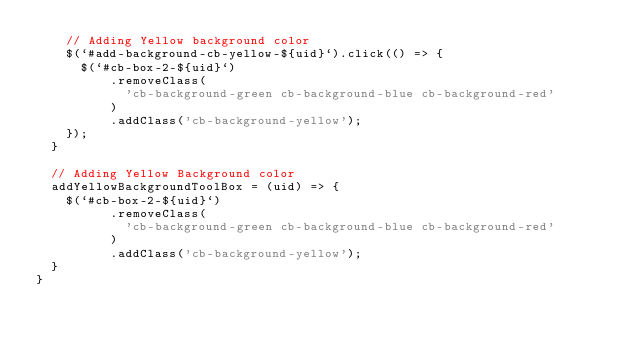<code> <loc_0><loc_0><loc_500><loc_500><_TypeScript_>    // Adding Yellow background color
    $(`#add-background-cb-yellow-${uid}`).click(() => {
      $(`#cb-box-2-${uid}`)
          .removeClass(
            'cb-background-green cb-background-blue cb-background-red'
          )
          .addClass('cb-background-yellow');
    });
  }

  // Adding Yellow Background color
  addYellowBackgroundToolBox = (uid) => {
    $(`#cb-box-2-${uid}`)
          .removeClass(
            'cb-background-green cb-background-blue cb-background-red'
          )
          .addClass('cb-background-yellow');
  }
}
</code> 